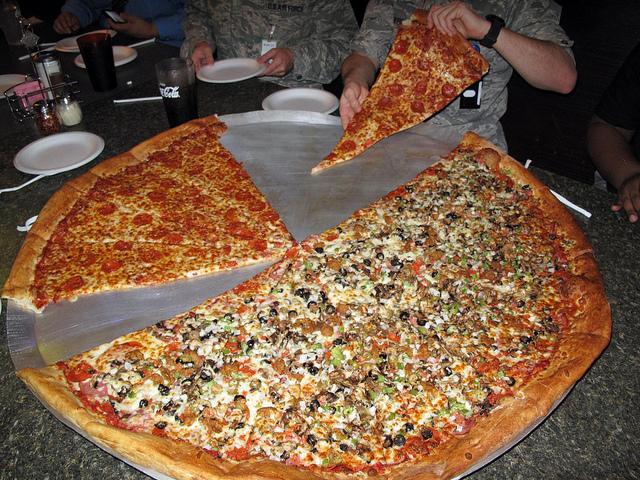What kind of plates are on the table?
Short answer required. Paper. Is this a lot of pizza?
Short answer required. Yes. Is there more than one kind of pizza?
Short answer required. Yes. 